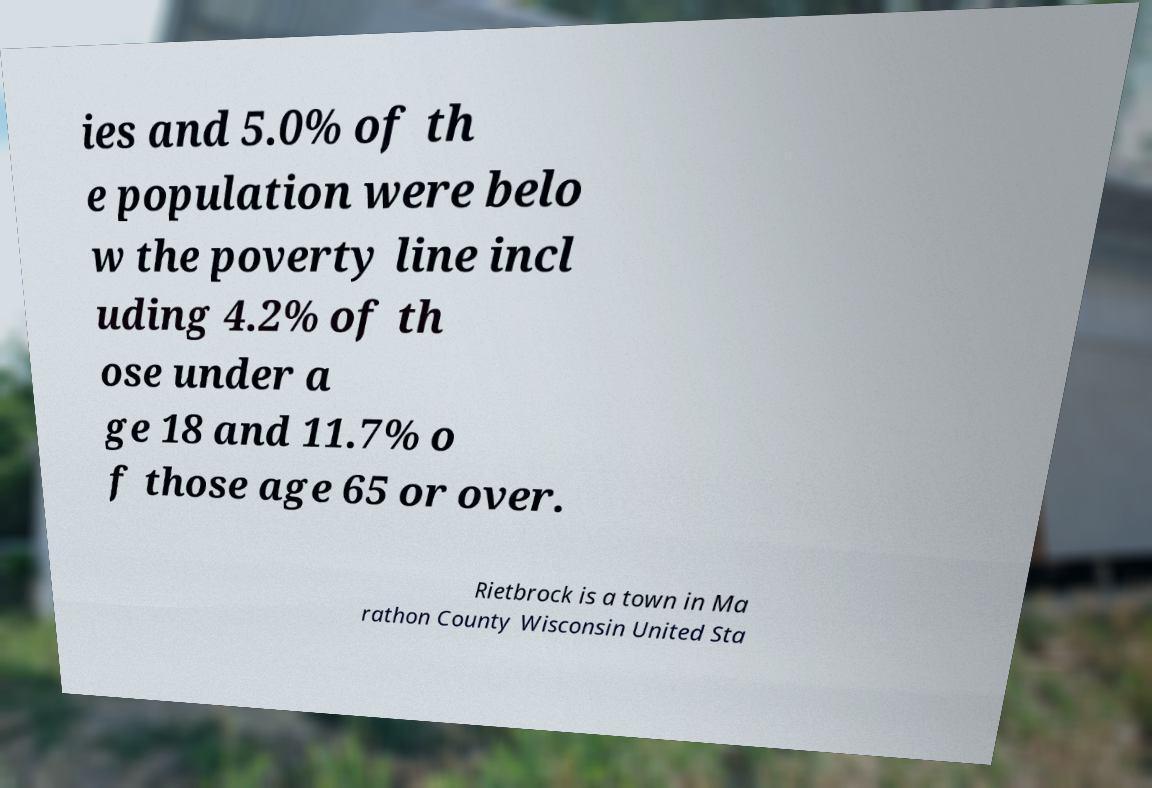There's text embedded in this image that I need extracted. Can you transcribe it verbatim? ies and 5.0% of th e population were belo w the poverty line incl uding 4.2% of th ose under a ge 18 and 11.7% o f those age 65 or over. Rietbrock is a town in Ma rathon County Wisconsin United Sta 